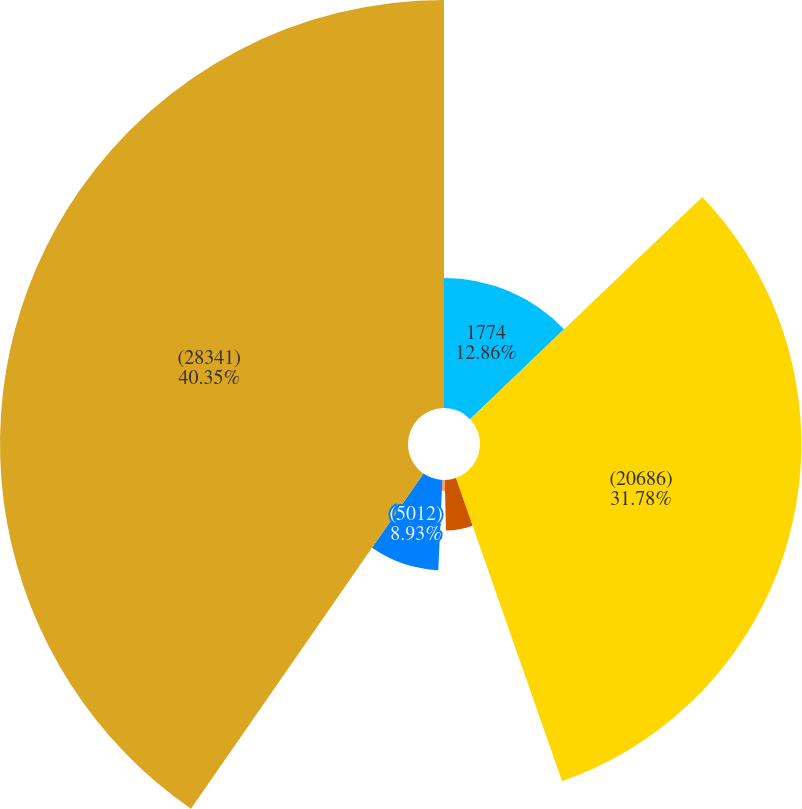Convert chart. <chart><loc_0><loc_0><loc_500><loc_500><pie_chart><fcel>1774<fcel>(20686)<fcel>(4772)<fcel>355<fcel>(5012)<fcel>(28341)<nl><fcel>12.86%<fcel>31.78%<fcel>5.0%<fcel>1.08%<fcel>8.93%<fcel>40.35%<nl></chart> 